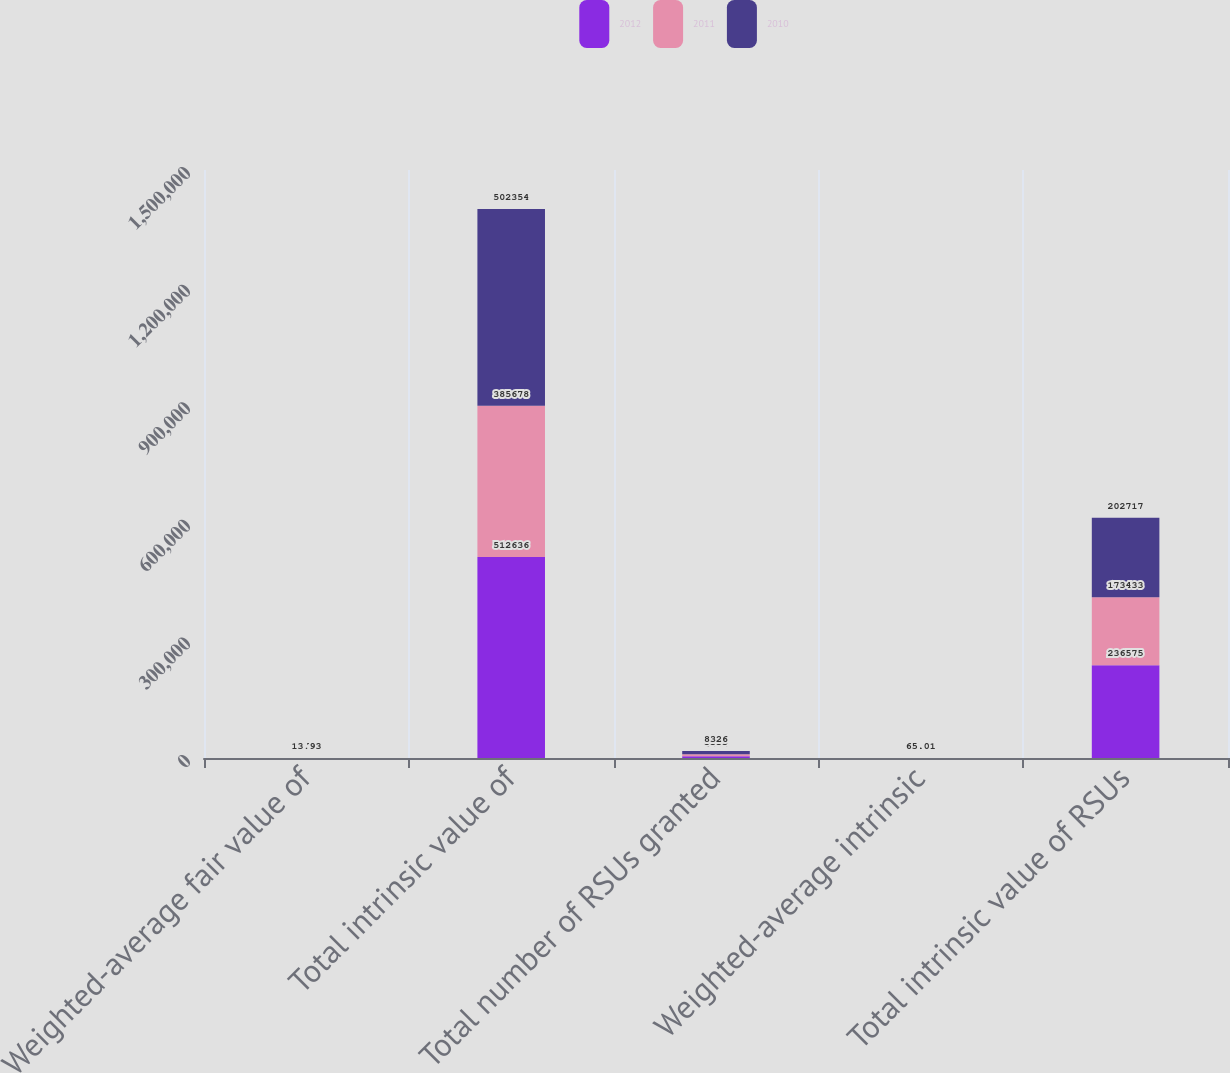Convert chart. <chart><loc_0><loc_0><loc_500><loc_500><stacked_bar_chart><ecel><fcel>Weighted-average fair value of<fcel>Total intrinsic value of<fcel>Total number of RSUs granted<fcel>Weighted-average intrinsic<fcel>Total intrinsic value of RSUs<nl><fcel>2012<fcel>6.86<fcel>512636<fcel>4404<fcel>66.64<fcel>236575<nl><fcel>2011<fcel>7.79<fcel>385678<fcel>5333<fcel>63.87<fcel>173433<nl><fcel>2010<fcel>13.93<fcel>502354<fcel>8326<fcel>65.01<fcel>202717<nl></chart> 